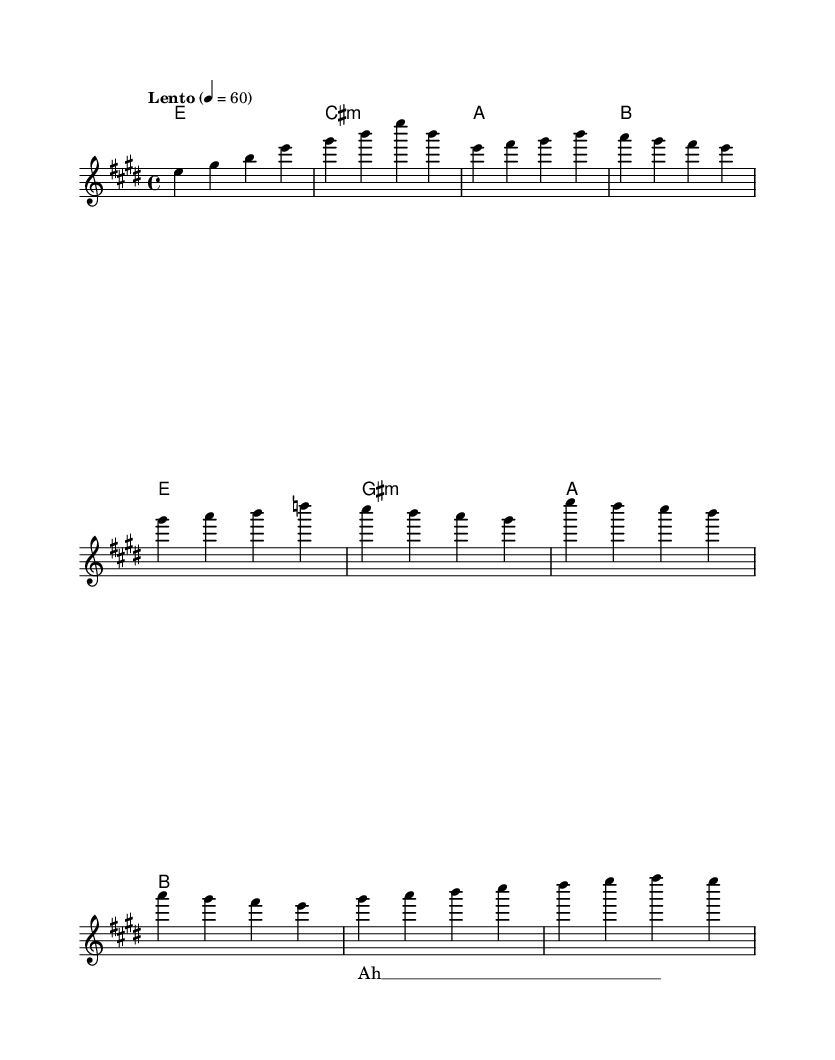What is the key signature of this music? The key signature is E major, which has four sharps (F#, C#, G#, D#). This can be determined by looking at the beginning of the music sheet where the key signature is indicated.
Answer: E major What is the time signature of this piece? The time signature is 4/4, meaning there are four beats per measure, and each quarter note gets one beat. This is shown at the beginning of the score next to the key signature.
Answer: 4/4 What is the tempo marking of this music? The tempo marking is "Lento," which indicates a slow tempo. The tempo is also specified as 4 = 60, meaning there are 60 beats per minute. This information is typically found at the start of the sheet music.
Answer: Lento How many measures are in the melody? There are a total of 8 measures in the melody. This can be counted from the start to the end of the melody line, including both the intro and verses.
Answer: 8 What chord follows the introduction section? The chord following the introduction is E major, represented by "e1" in the harmonies. The first measure in the harmony section indicates this chord directly after the introduction.
Answer: E major What is the primary theme of the lyrics suggested by the notation? The primary theme suggested by the lyrics is worship, symbolized by the repeated "Ah" in the lyrics indicating a sense of ethereal reverence. This is inferred from the lyrics section that shows the placeholder for the text matched to the melody.
Answer: Worship Which section of the music contains the highest pitch? The chorus section contains the highest pitch, where the melody reaches E'4 at the start of that section. Observing the melodic line indicates that the notes in the chorus ascend to a higher pitch than previous sections.
Answer: Chorus 